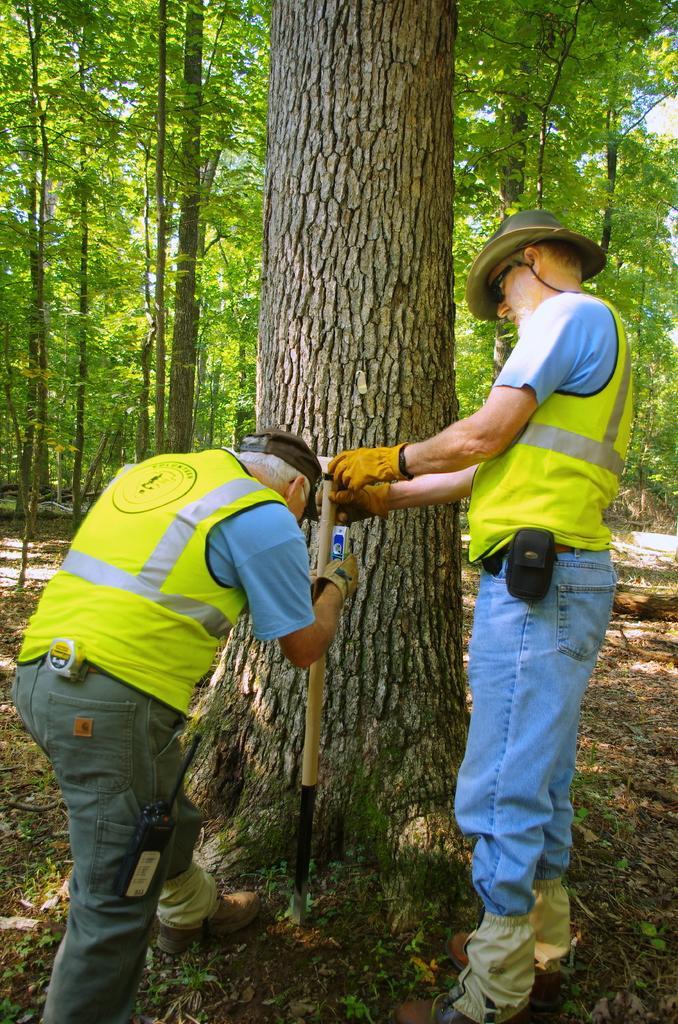Please provide a concise description of this image. In this image I can see two men are standing in the front and I can see both of them are holding a stick. I can also see both of them are wearing caps, jackets, jeans, shoes and gloves. I can also see number of trees in the background. 